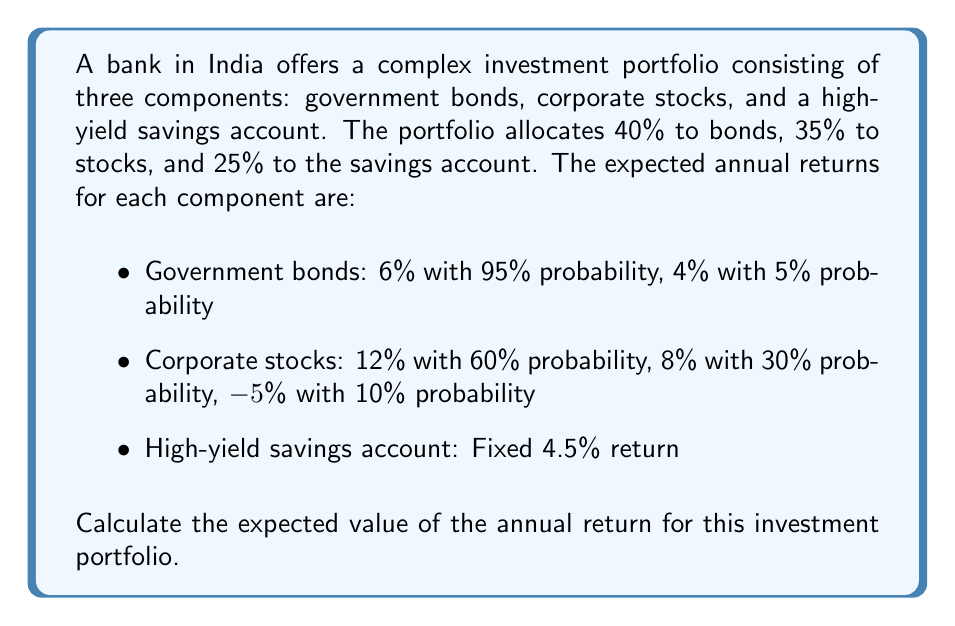Help me with this question. To calculate the expected value of the portfolio's annual return, we need to:

1. Calculate the expected return for each component
2. Weight each component's expected return by its allocation in the portfolio
3. Sum the weighted expected returns

Step 1: Calculate expected returns for each component

a) Government bonds:
$E(bonds) = 0.95 \times 6\% + 0.05 \times 4\% = 5.9\%$

b) Corporate stocks:
$E(stocks) = 0.60 \times 12\% + 0.30 \times 8\% + 0.10 \times (-5\%) = 8.9\%$

c) High-yield savings account:
$E(savings) = 4.5\%$ (fixed return)

Step 2: Weight each component's expected return

a) Government bonds: $40\% \times 5.9\% = 2.36\%$
b) Corporate stocks: $35\% \times 8.9\% = 3.115\%$
c) High-yield savings: $25\% \times 4.5\% = 1.125\%$

Step 3: Sum the weighted expected returns

$E(portfolio) = 2.36\% + 3.115\% + 1.125\% = 6.6\%$

Therefore, the expected value of the annual return for this investment portfolio is 6.6%.
Answer: 6.6% 